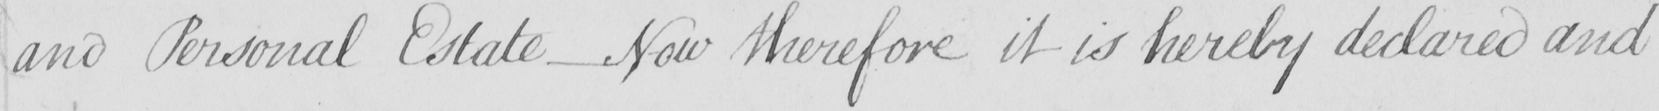Please transcribe the handwritten text in this image. and Personal Estate _ Now therefore it is hereby declared and 